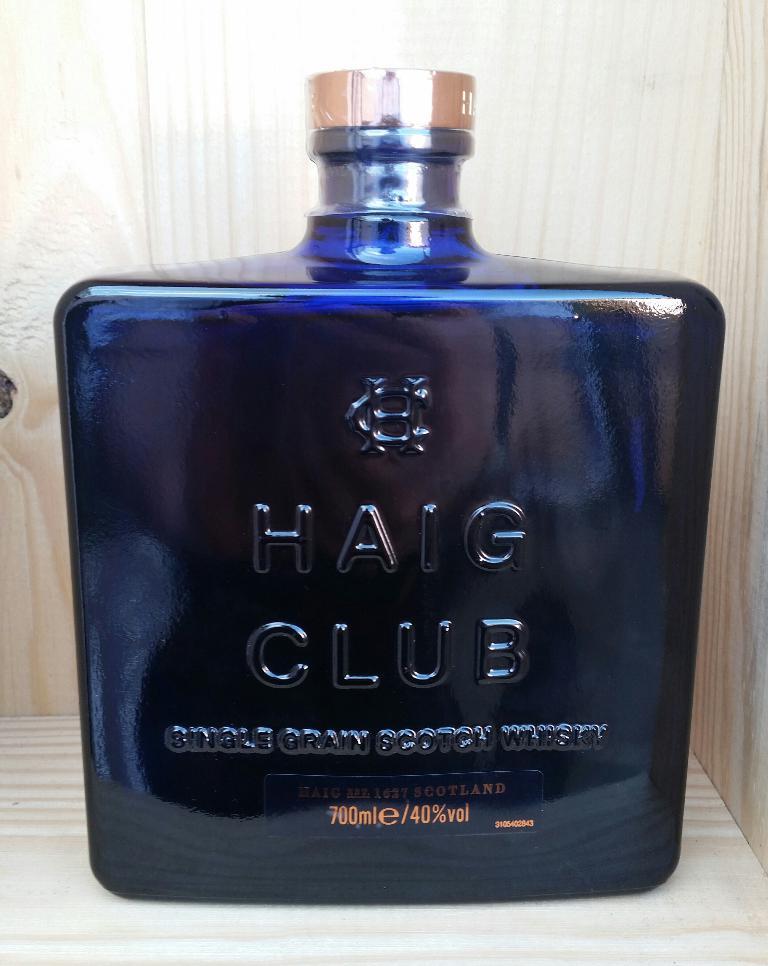How many milliliters does this have?
Keep it short and to the point. 700. 